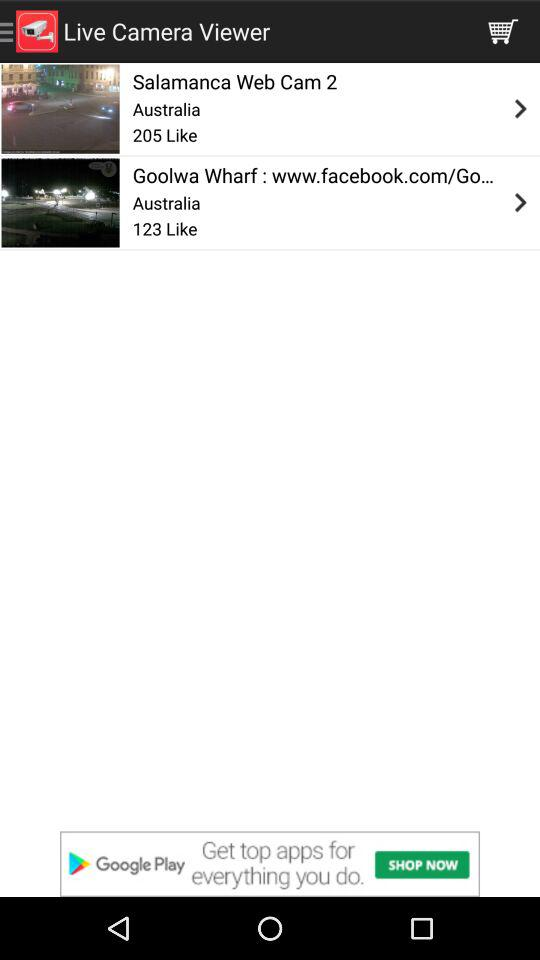How many more likes does the Salamanca web cam have than the Goolwa Wharf web cam?
Answer the question using a single word or phrase. 82 